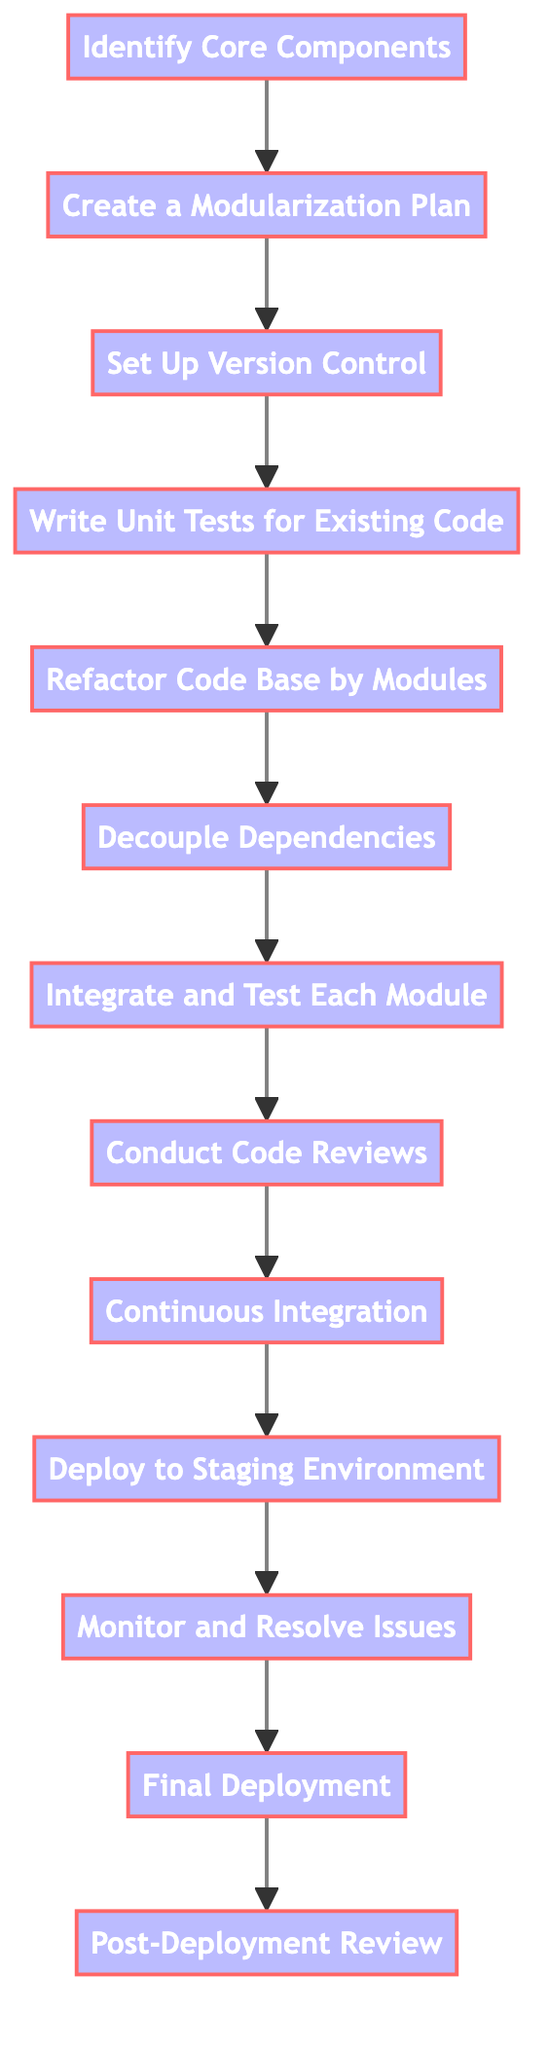What is the first step in the refactoring process? The diagram indicates that the first step in the process is to identify core components, which is represented by the first node in the flowchart.
Answer: Identify Core Components How many processes are represented in the diagram? By counting the nodes labeled as processes in the flowchart, there are a total of thirteen distinct processes that guide the refactoring effort.
Answer: 13 What is the last step before final deployment? From the flowchart, the last step leading up to the final deployment is the monitoring and resolving of issues, which is the eleventh process in the sequence.
Answer: Monitor and Resolve Issues Which step follows integrating and testing each module? The flowchart shows that after the integration and testing of each module, the next step is conducting code reviews. This is the eighth step in the process.
Answer: Conduct Code Reviews What needs to be ensured before beginning the refactoring process? According to the flowchart, it is essential to set up version control to track changes before starting the refactoring process. This is outlined as the third step.
Answer: Set Up Version Control How does the refactoring process handle dependencies? The process involves decoupling dependencies, which is the sixth step in the diagram, aimed at isolating tightly-bound dependencies within the legacy codebase for better modularization.
Answer: Decouple Dependencies What happens after drafting a modularization plan? After creating a modularization plan, the next action is to set up version control, which ensures that the codebase is tracked for changes during the refactoring process.
Answer: Set Up Version Control How many steps are there between creating a modularization plan and deploying to a staging environment? To determine the number, count the steps in the flowchart between creating the modularization plan (step 2) and deploying to the staging environment (step 10). There are a total of seven steps in between.
Answer: 7 